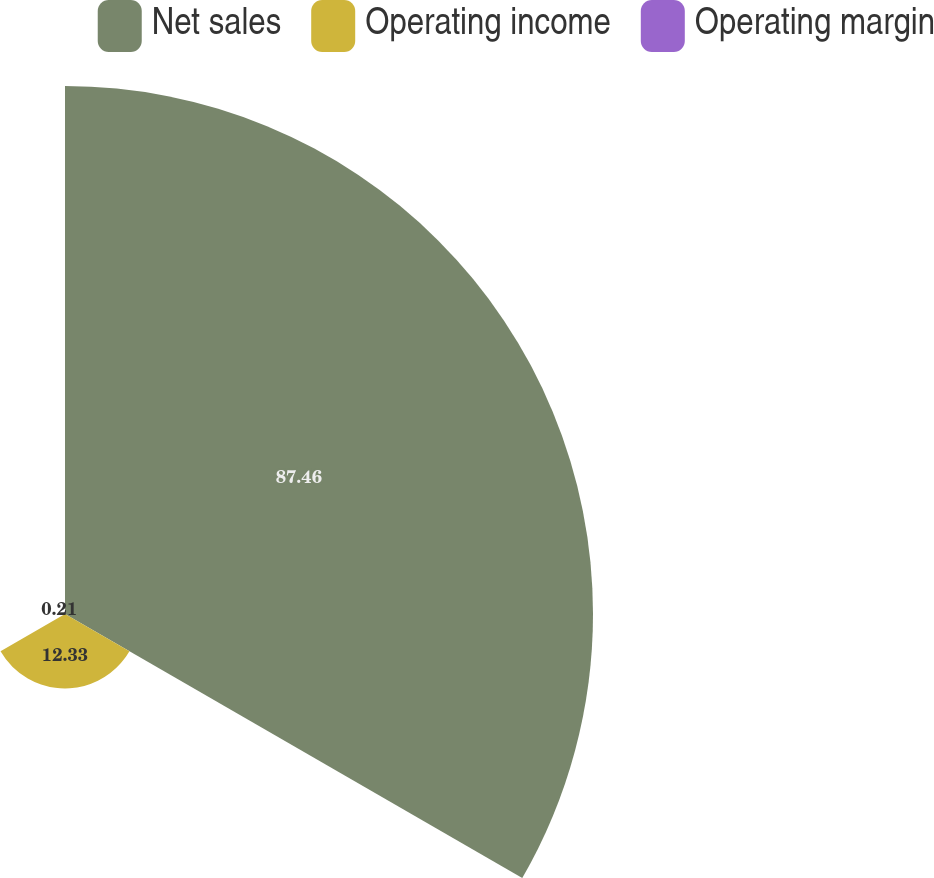Convert chart to OTSL. <chart><loc_0><loc_0><loc_500><loc_500><pie_chart><fcel>Net sales<fcel>Operating income<fcel>Operating margin<nl><fcel>87.46%<fcel>12.33%<fcel>0.21%<nl></chart> 